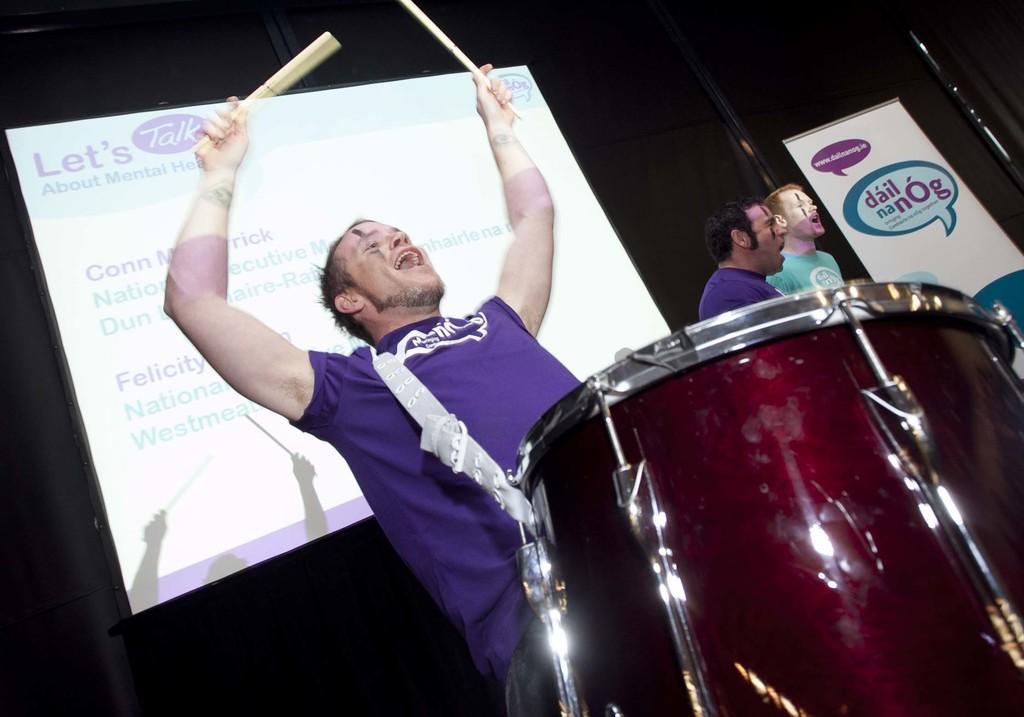Describe this image in one or two sentences. In front of the image there is a man standing and holding sticks in his hands. And there is a musical instrument. Beside him there are two men. In the background there is a screen with text. Behind the screen there are black curtains. On the right side of the image there is a banner with text on it. 